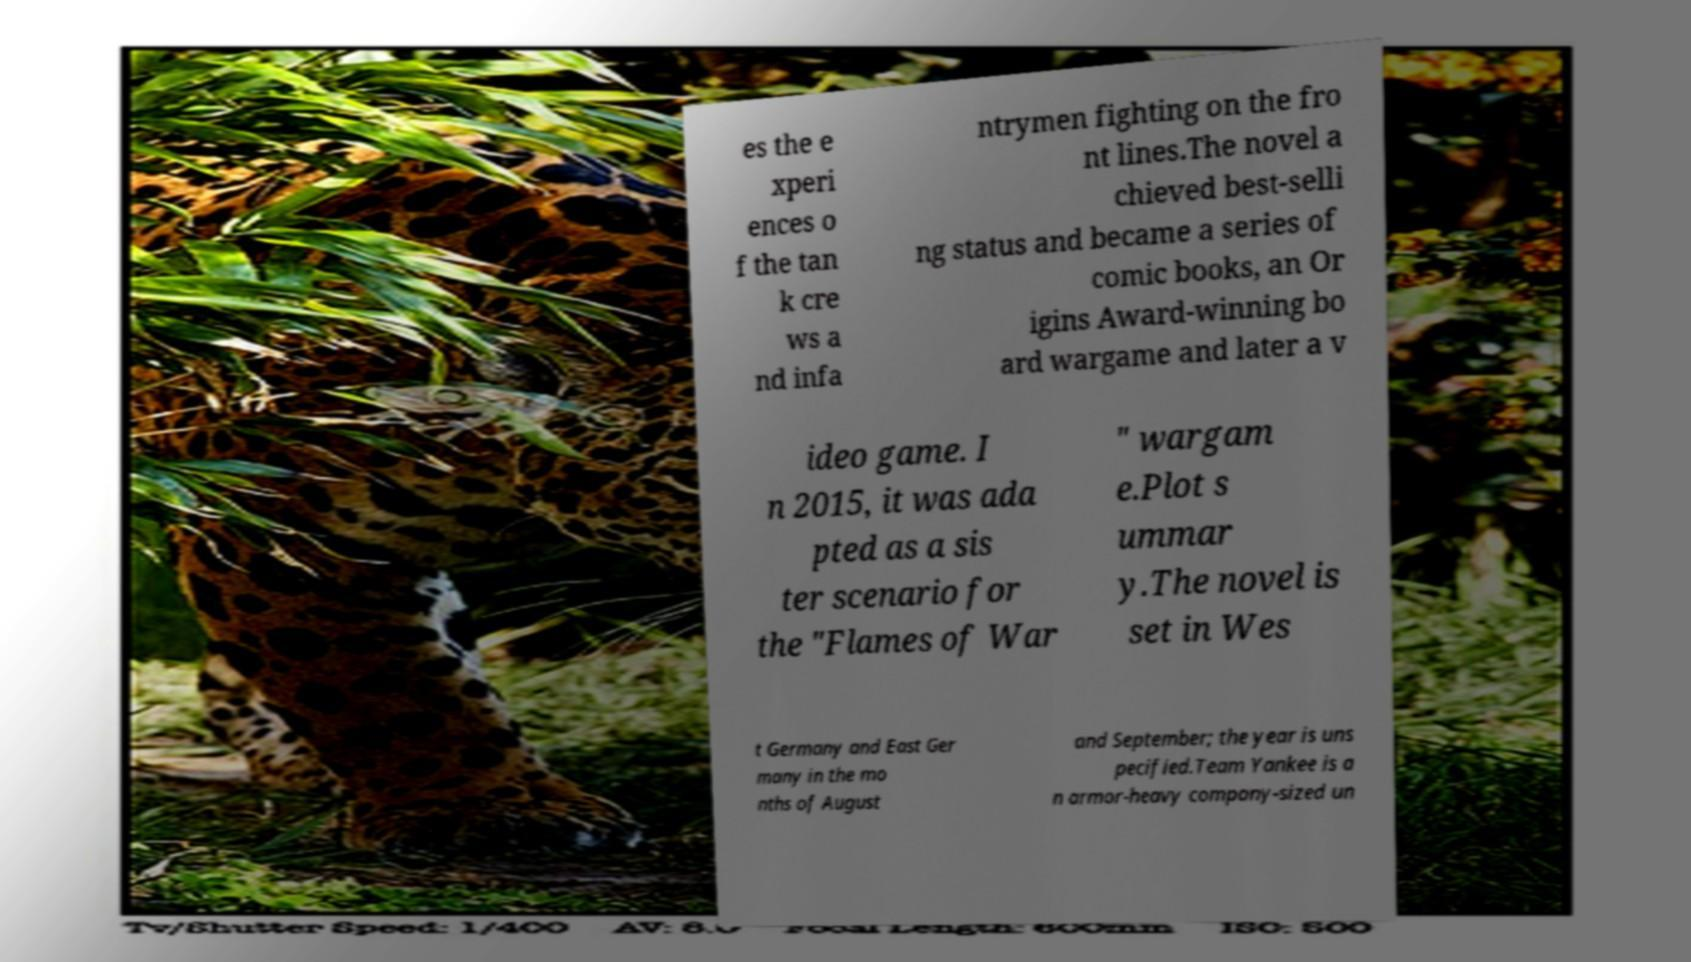Please identify and transcribe the text found in this image. es the e xperi ences o f the tan k cre ws a nd infa ntrymen fighting on the fro nt lines.The novel a chieved best-selli ng status and became a series of comic books, an Or igins Award-winning bo ard wargame and later a v ideo game. I n 2015, it was ada pted as a sis ter scenario for the "Flames of War " wargam e.Plot s ummar y.The novel is set in Wes t Germany and East Ger many in the mo nths of August and September; the year is uns pecified.Team Yankee is a n armor-heavy company-sized un 